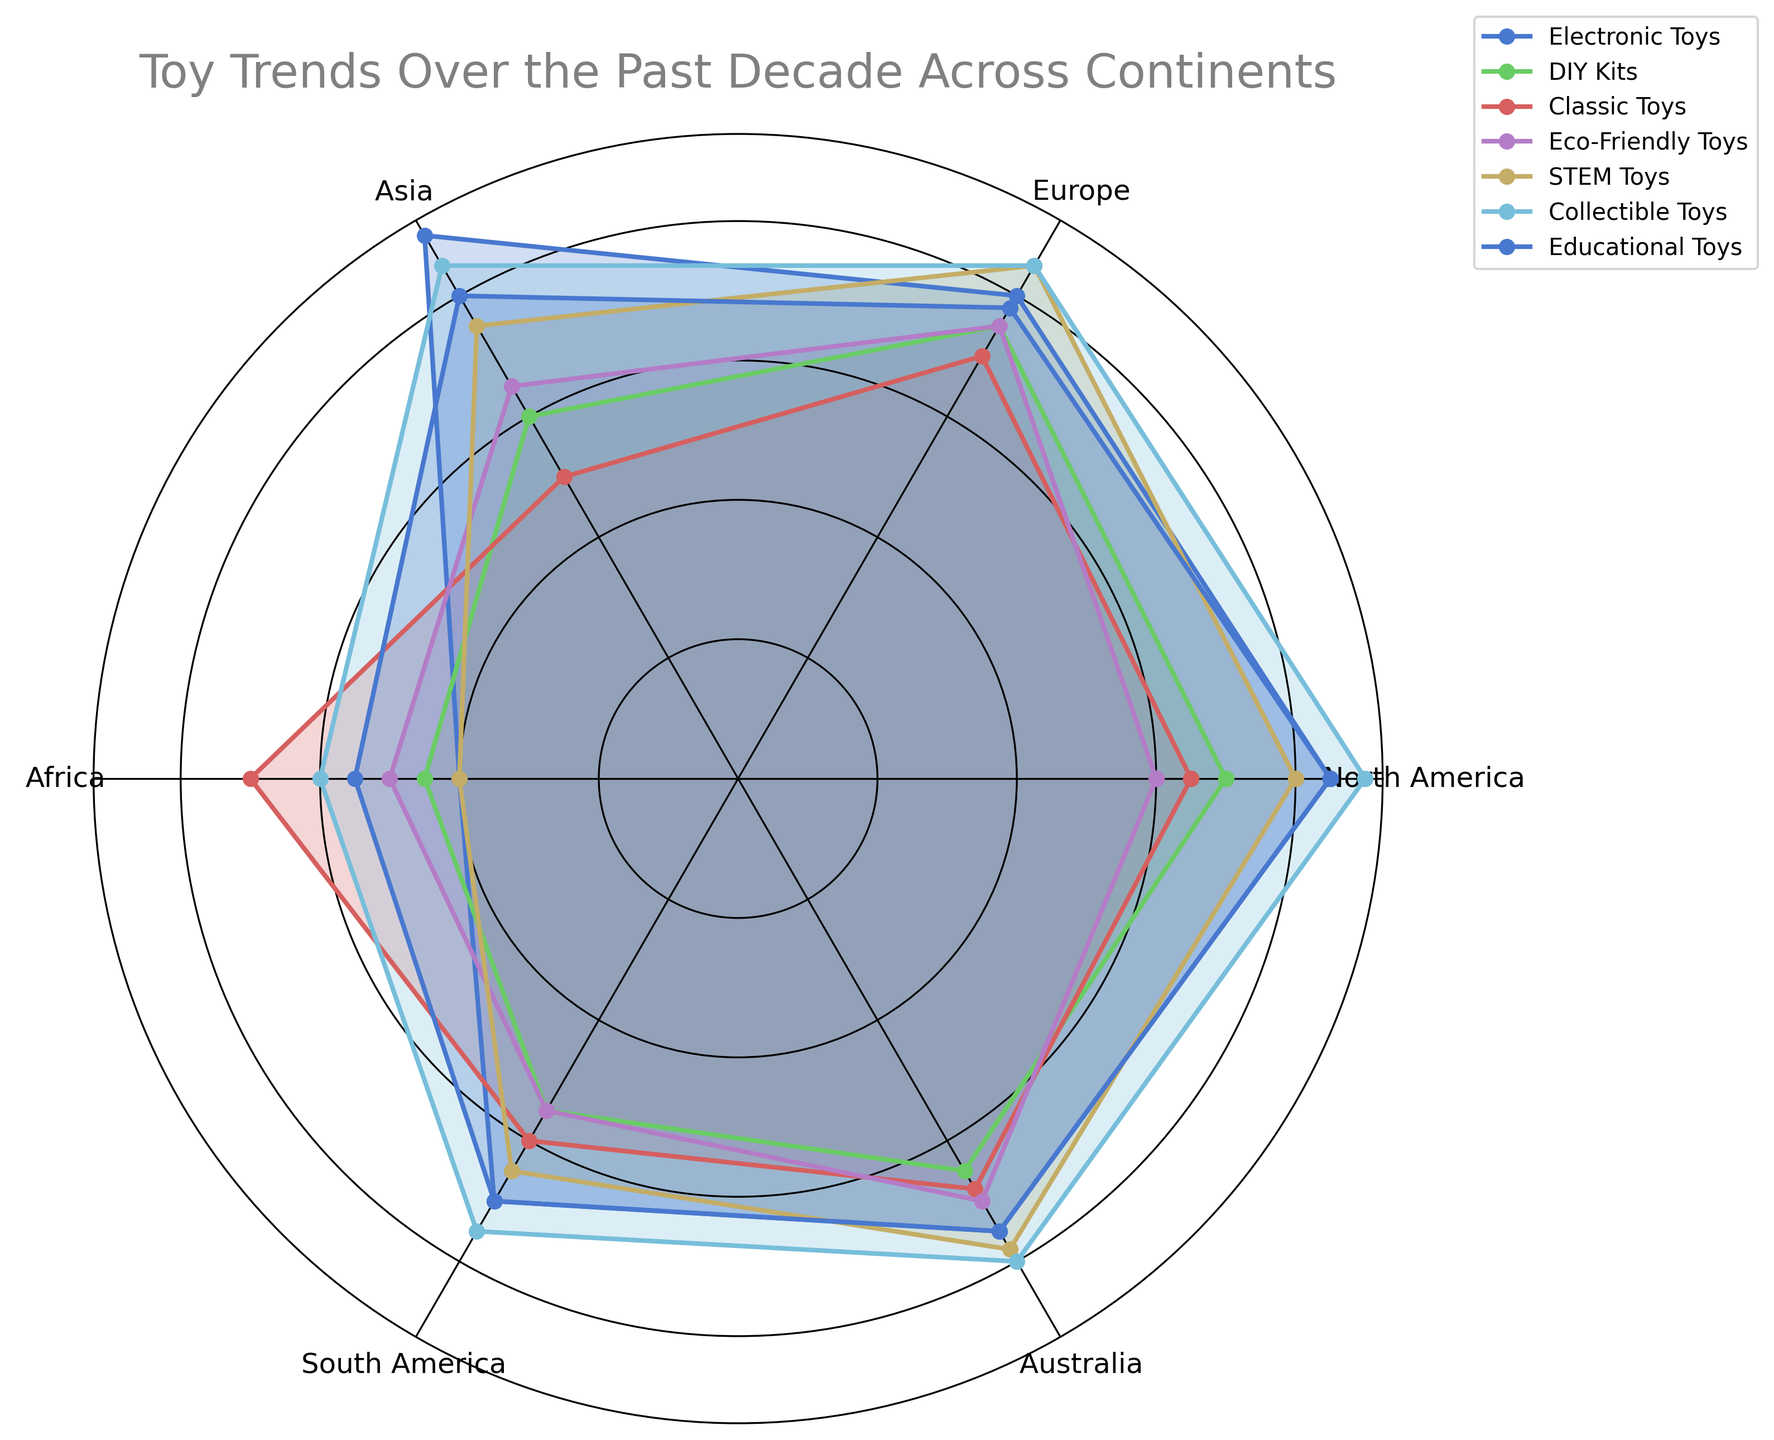Which continent has the highest popularity for Electronic Toys? North America has an 85 value for Electronic Toys which is higher compared to other continents' values (Europe: 80, Asia: 90, Africa: 40, South America: 70, Australia: 75). By observing the graph's peaks, Asia has the highest value.
Answer: Asia Which type of toy has the lowest popularity in Africa? By examining the lower-bound values on the radar chart under Africa, Electronic Toys and STEM Toys both have the lowest value of 40.
Answer: Electronic Toys and STEM Toys What is the average popularity of Eco-Friendly Toys across all continents? The values for Eco-Friendly Toys are North America: 60, Europe: 75, Asia: 65, Africa: 50, South America: 55, Australia: 70. Summing these values gives 375; dividing by the number of continents (6) results in 62.5.
Answer: 62.5 Which toy categories have a popularity above 80 in Europe? Looking at Europe's axis, Electronic Toys, STEM Toys, and Collectible Toys all exceed the 80 value line.
Answer: Electronic Toys, STEM Toys, Collectible Toys What is the difference between the popularity of Electronic Toys and Classic Toys in North America? The values for Electronic Toys and Classic Toys in North America are 85 and 65, respectively. The difference is 85 - 65 = 20.
Answer: 20 How does the popularity of DIY kits compare across different continents? DIY Kits' values are as follows: North America: 70, Europe: 75, Asia: 60, Africa: 45, South America: 55, Australia: 65. Europe has the highest value at 75, and Africa has the lowest at 45, showing significant variability.
Answer: Europe highest, Africa lowest Which continent has the most balanced popularity across all toy categories? By visually inspecting the radar chart for evenly spread values among all toy categories, Australia shows less fluctuation, maintaining relatively consistent values compared to other continents.
Answer: Australia In which continents are STEM Toys equally popular? The values for STEM Toys are North America: 80, Europe: 85, Asia: 75, Africa: 40, South America: 65, Australia: 78. No two continents have identical values, though North America and Australia are quite close.
Answer: None 